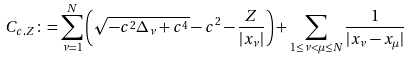Convert formula to latex. <formula><loc_0><loc_0><loc_500><loc_500>C _ { c , Z } \colon = \sum _ { \nu = 1 } ^ { N } \left ( \sqrt { - c ^ { 2 } \Delta _ { \nu } + c ^ { 4 } } - c ^ { 2 } - \frac { Z } { | x _ { \nu } | } \right ) + \sum _ { 1 \leq \nu < \mu \leq N } \frac { 1 } { | x _ { \nu } - x _ { \mu } | }</formula> 